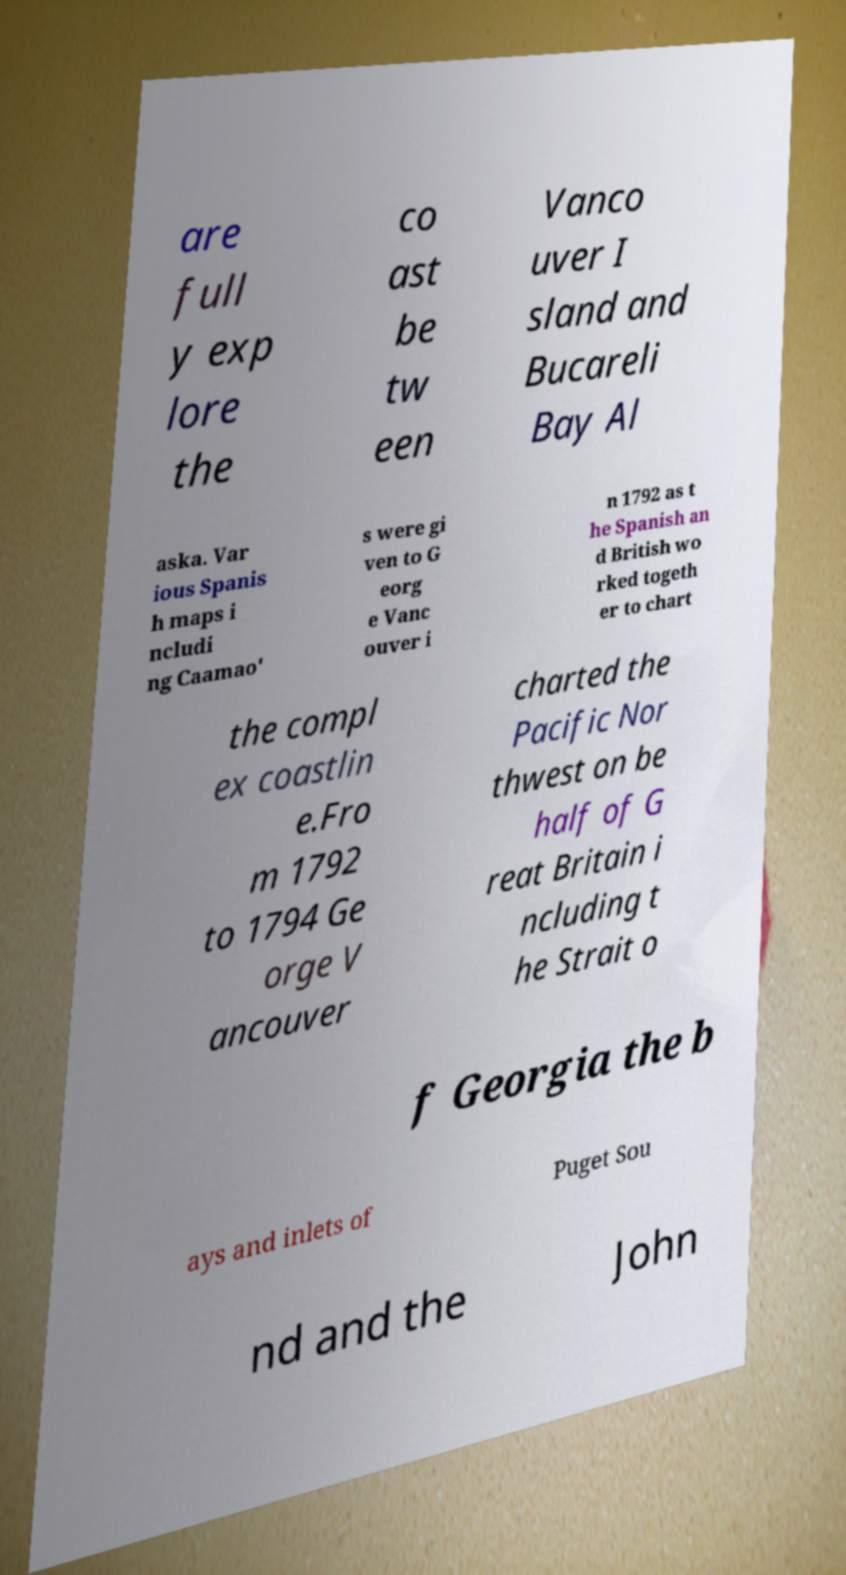What messages or text are displayed in this image? I need them in a readable, typed format. are full y exp lore the co ast be tw een Vanco uver I sland and Bucareli Bay Al aska. Var ious Spanis h maps i ncludi ng Caamao' s were gi ven to G eorg e Vanc ouver i n 1792 as t he Spanish an d British wo rked togeth er to chart the compl ex coastlin e.Fro m 1792 to 1794 Ge orge V ancouver charted the Pacific Nor thwest on be half of G reat Britain i ncluding t he Strait o f Georgia the b ays and inlets of Puget Sou nd and the John 